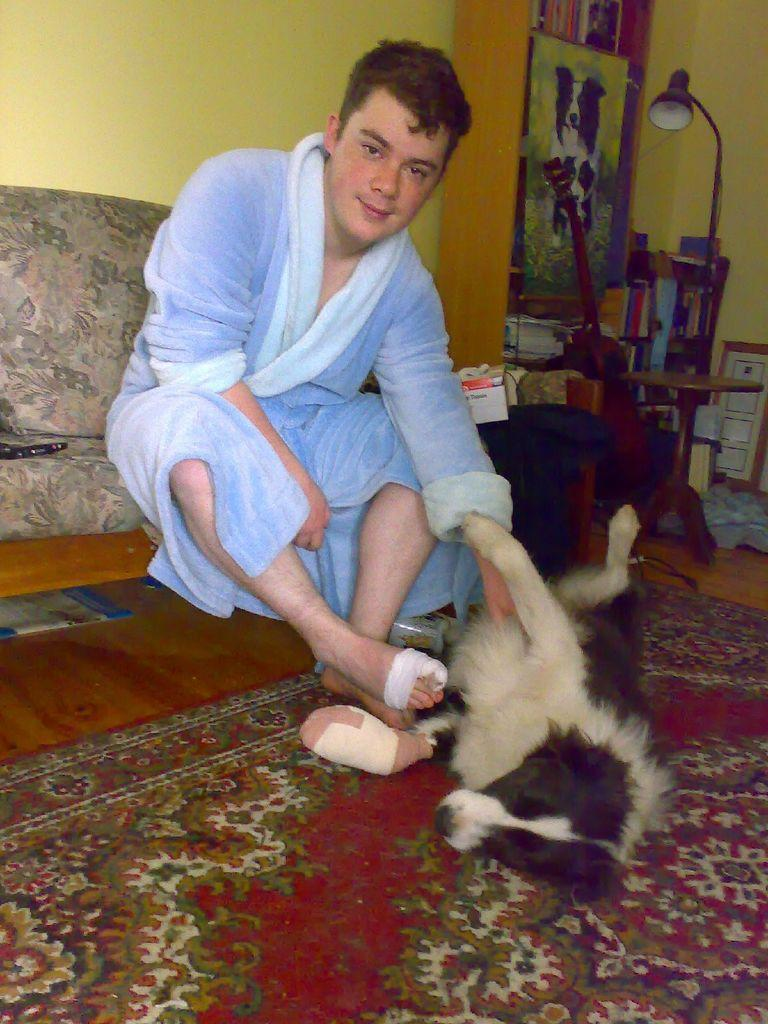Who is present in the image? There is a man in the image. What is the man doing in the image? The man is smiling in the image. Where is the man sitting in the image? The man is sitting on a sofa in the image. What is the man holding in the image? The man is holding a dog in front of him in the image. What objects can be seen on the table in the image? There are books and a lamp on the table in the image. What is visible on the wall in the image? There is a wall visible in the image. What type of stem can be seen growing from the dog in the image? There is no stem growing from the dog in the image; it is a dog, not a plant. 